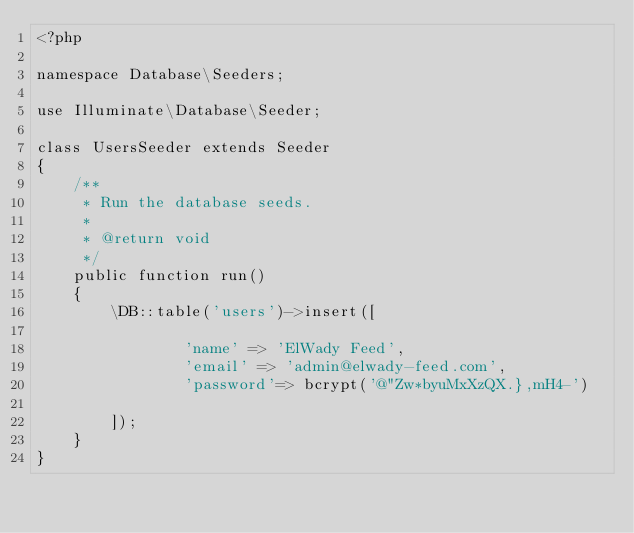<code> <loc_0><loc_0><loc_500><loc_500><_PHP_><?php

namespace Database\Seeders;

use Illuminate\Database\Seeder;

class UsersSeeder extends Seeder
{
    /**
     * Run the database seeds.
     *
     * @return void
     */
    public function run()
    {
        \DB::table('users')->insert([
            
                'name' => 'ElWady Feed',
                'email' => 'admin@elwady-feed.com',
                'password'=> bcrypt('@"Zw*byuMxXzQX.},mH4-')
            
        ]);
    }
}
</code> 